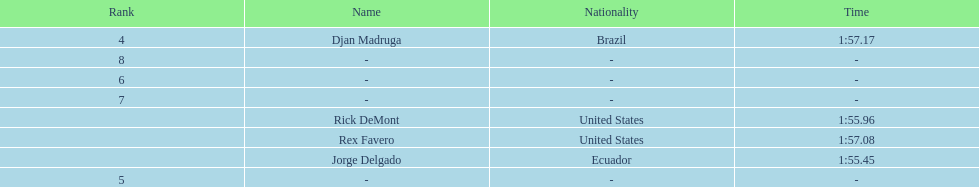How many ranked swimmers were from the united states? 2. 